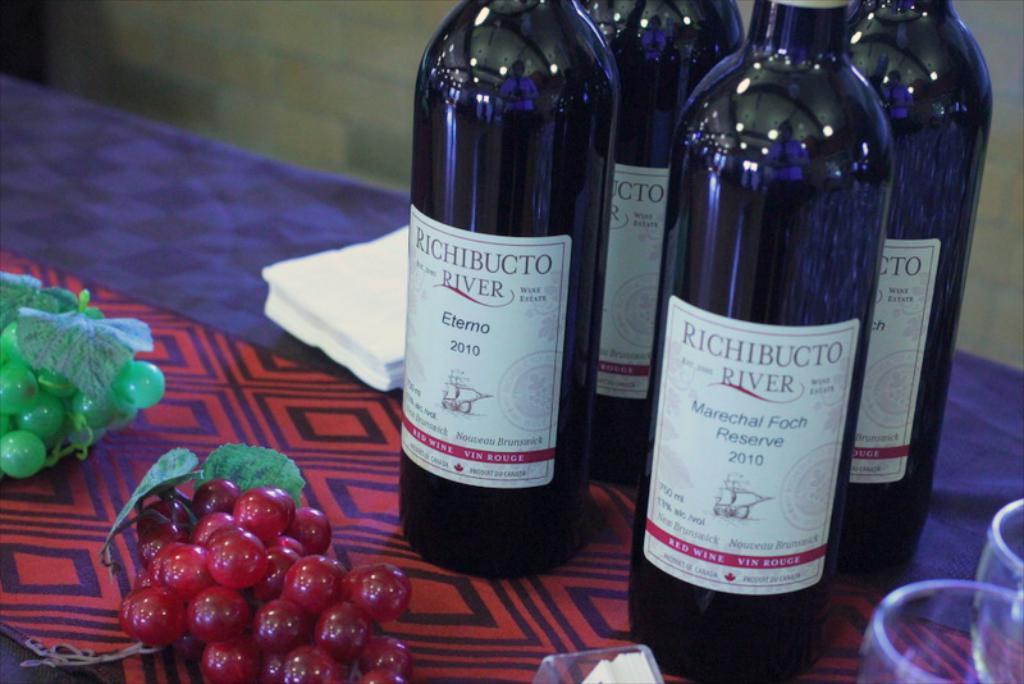What brand is the wine?
Your answer should be very brief. Richibucto river. What year is on the wine bottle?
Ensure brevity in your answer.  2010. 